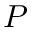<formula> <loc_0><loc_0><loc_500><loc_500>P</formula> 